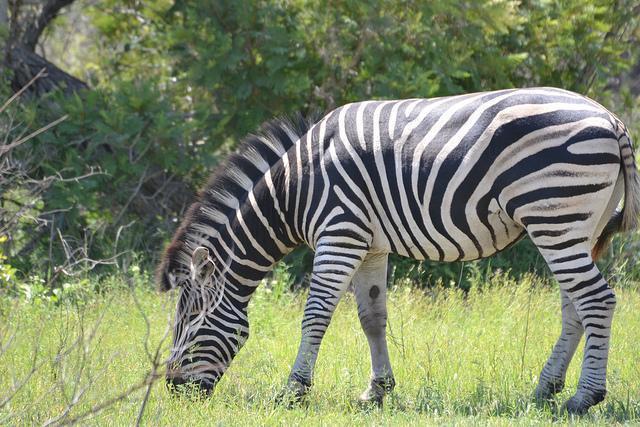How many pizzas have been half-eaten?
Give a very brief answer. 0. 